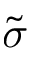<formula> <loc_0><loc_0><loc_500><loc_500>\tilde { \sigma }</formula> 